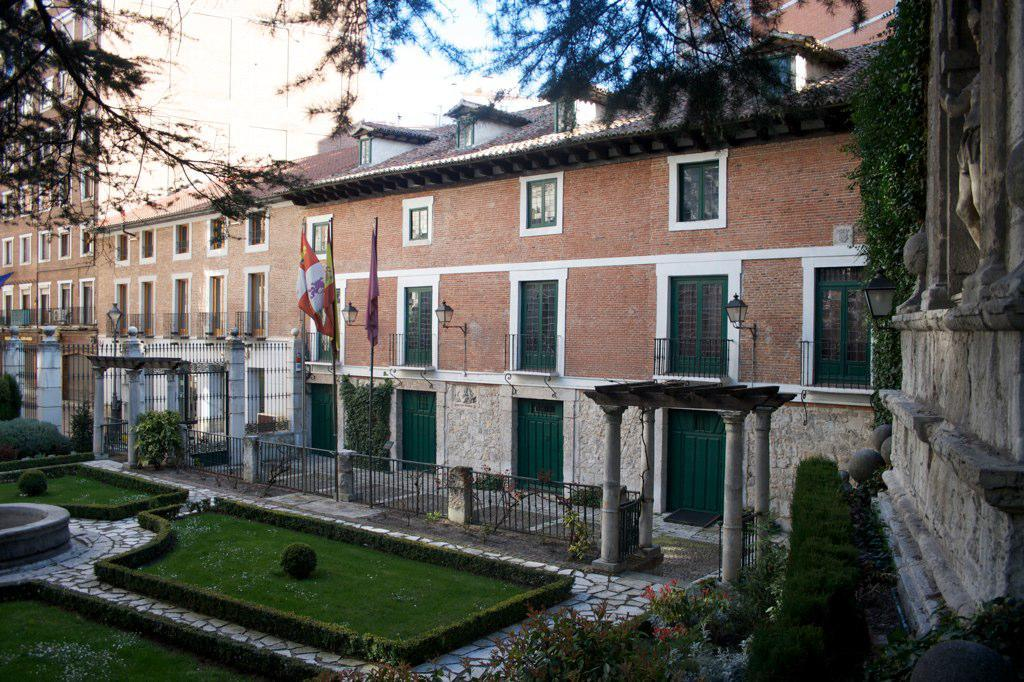What type of structures can be seen in the image? There are buildings in the image. What decorative or symbolic objects are present in the image? There are flags in the image. What type of barrier can be seen in the image? There is a fence in the image. What is the ground surface like in front of the buildings? There is a greenery ground in front of the buildings. What type of vegetation is present in the image? There are plants in the image. Where is another type of barrier located in the image? There is a fence wall in the right corner of the image. How many tomatoes are hanging from the fence in the image? There are no tomatoes present in the image; it features a fence wall in the right corner. What type of nail is used to attach the flags to the buildings? There is no mention of nails in the image, and the flags are not attached to the buildings. 